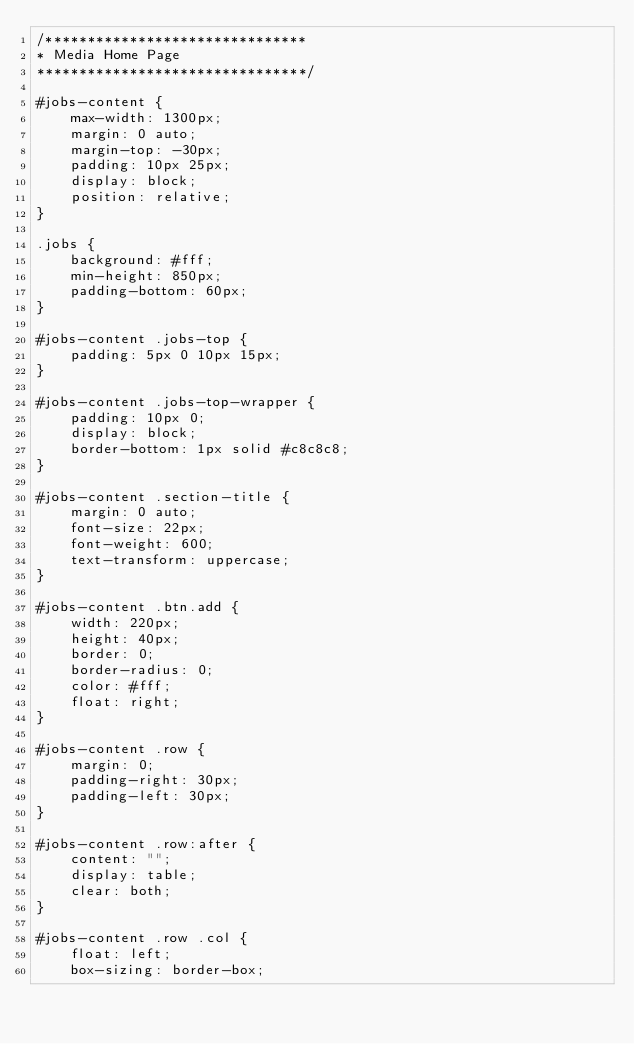Convert code to text. <code><loc_0><loc_0><loc_500><loc_500><_CSS_>/*******************************
* Media Home Page
********************************/

#jobs-content {
    max-width: 1300px;
    margin: 0 auto;
    margin-top: -30px;
    padding: 10px 25px;
    display: block;
    position: relative;
}

.jobs {
    background: #fff;
    min-height: 850px;
    padding-bottom: 60px;
}

#jobs-content .jobs-top {
    padding: 5px 0 10px 15px;
}

#jobs-content .jobs-top-wrapper {
    padding: 10px 0;
    display: block;
    border-bottom: 1px solid #c8c8c8;
}

#jobs-content .section-title {
    margin: 0 auto;
    font-size: 22px;
    font-weight: 600;
    text-transform: uppercase;
}

#jobs-content .btn.add {
    width: 220px;
    height: 40px;
    border: 0;
    border-radius: 0;
    color: #fff;
    float: right;
}

#jobs-content .row {
    margin: 0;
    padding-right: 30px;
    padding-left: 30px;
}

#jobs-content .row:after {
    content: "";
    display: table;
    clear: both;
}

#jobs-content .row .col {
    float: left;
    box-sizing: border-box;</code> 